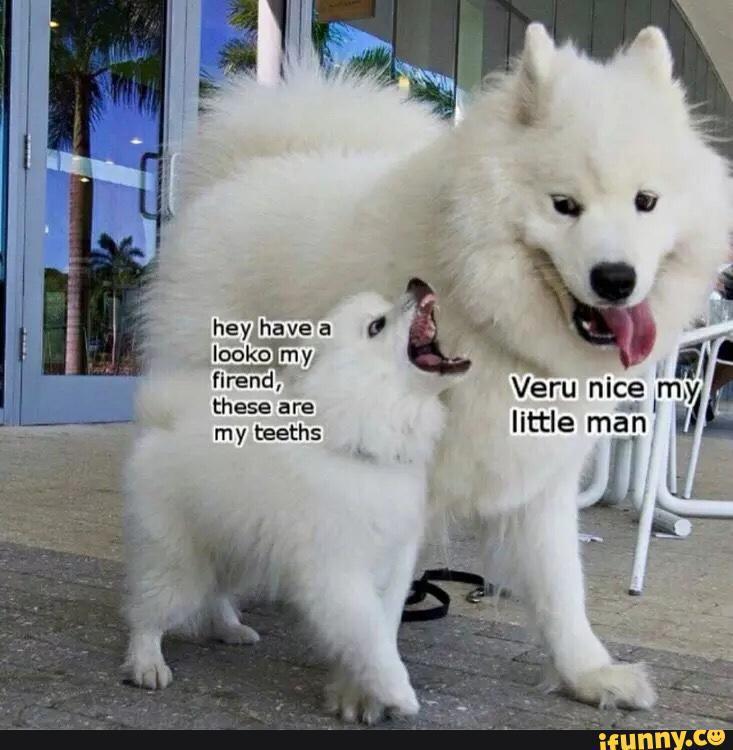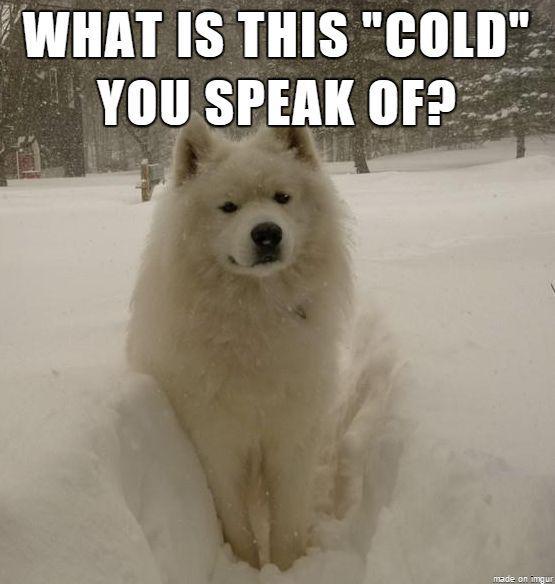The first image is the image on the left, the second image is the image on the right. Considering the images on both sides, is "There are at least three fluffy white dogs." valid? Answer yes or no. Yes. The first image is the image on the left, the second image is the image on the right. Examine the images to the left and right. Is the description "In one image, a large white dog is balanced on its hind legs beside a dark brown coffee table." accurate? Answer yes or no. No. 